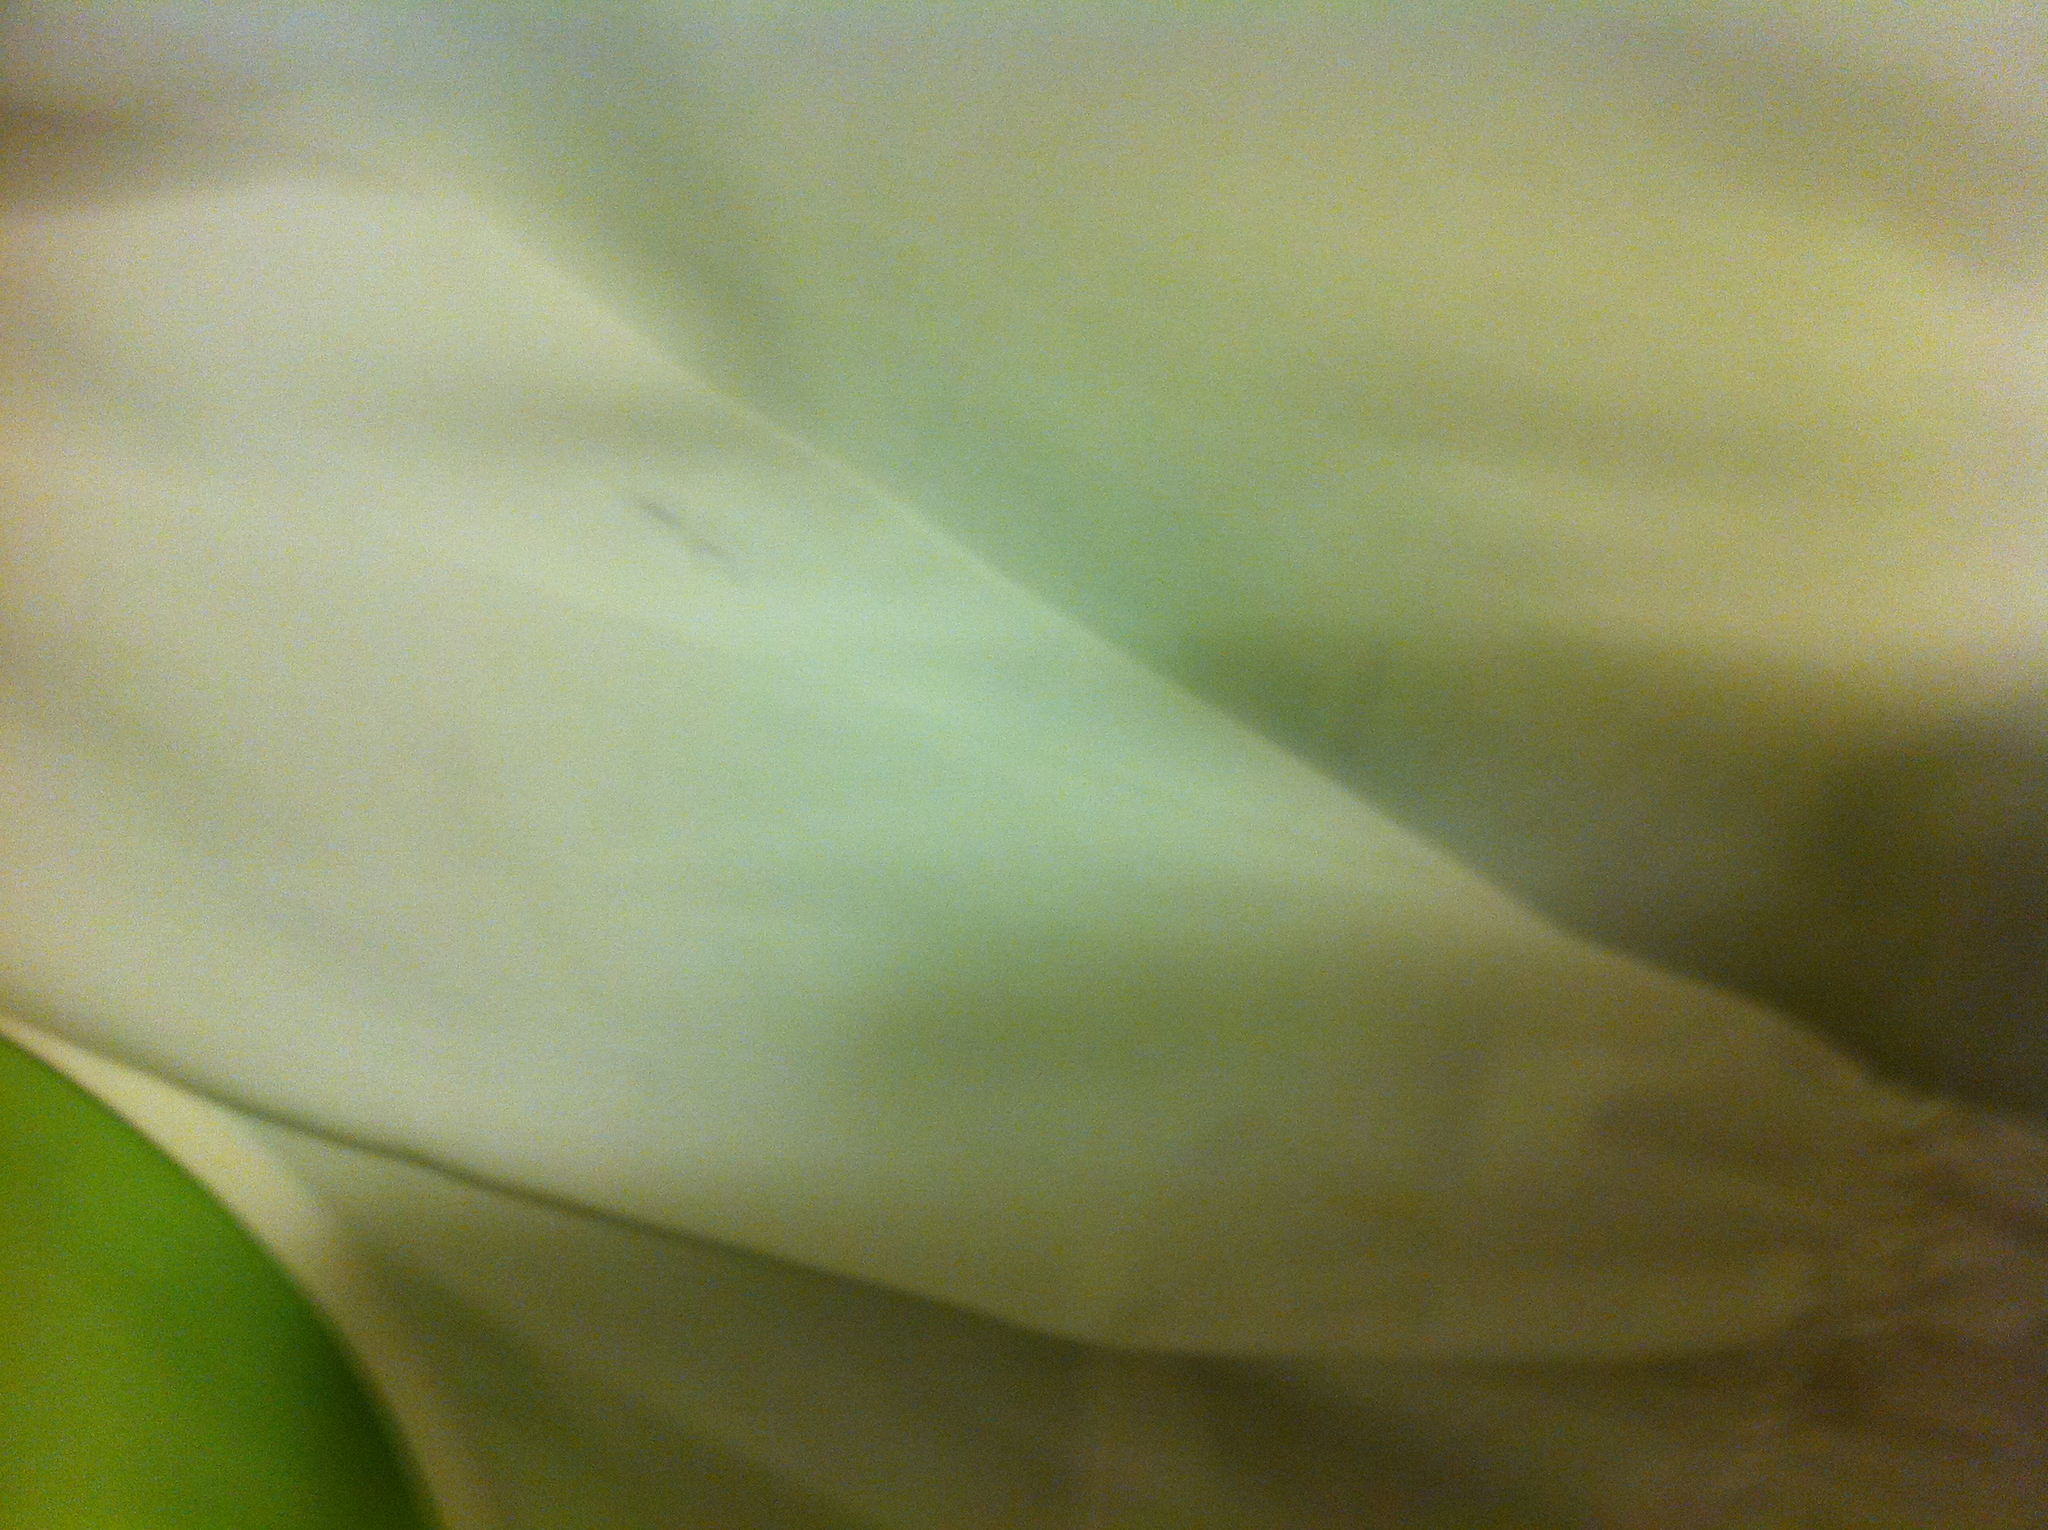Can you tell me more about the fabric of the shirt? The fabric seems to be of a light, airy quality, often associated with cotton or a cotton blend. It's the type of material that would be breathable and gentle on the skin, suitable for casual wear. 